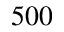Convert formula to latex. <formula><loc_0><loc_0><loc_500><loc_500>5 0 0</formula> 